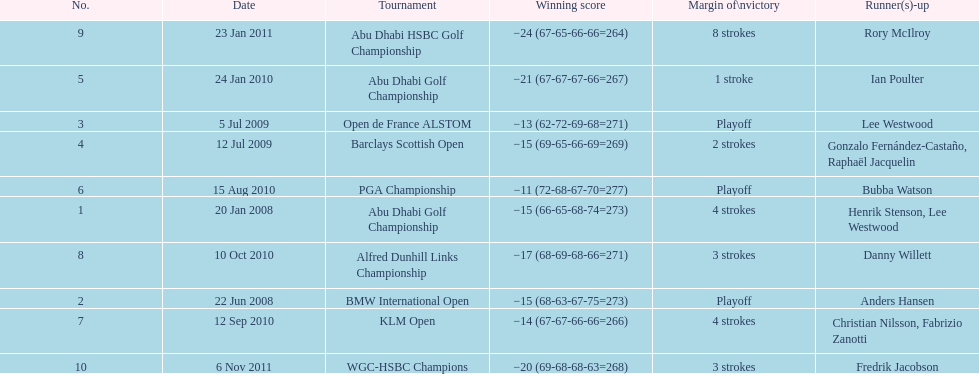How many total tournaments has he won? 10. 